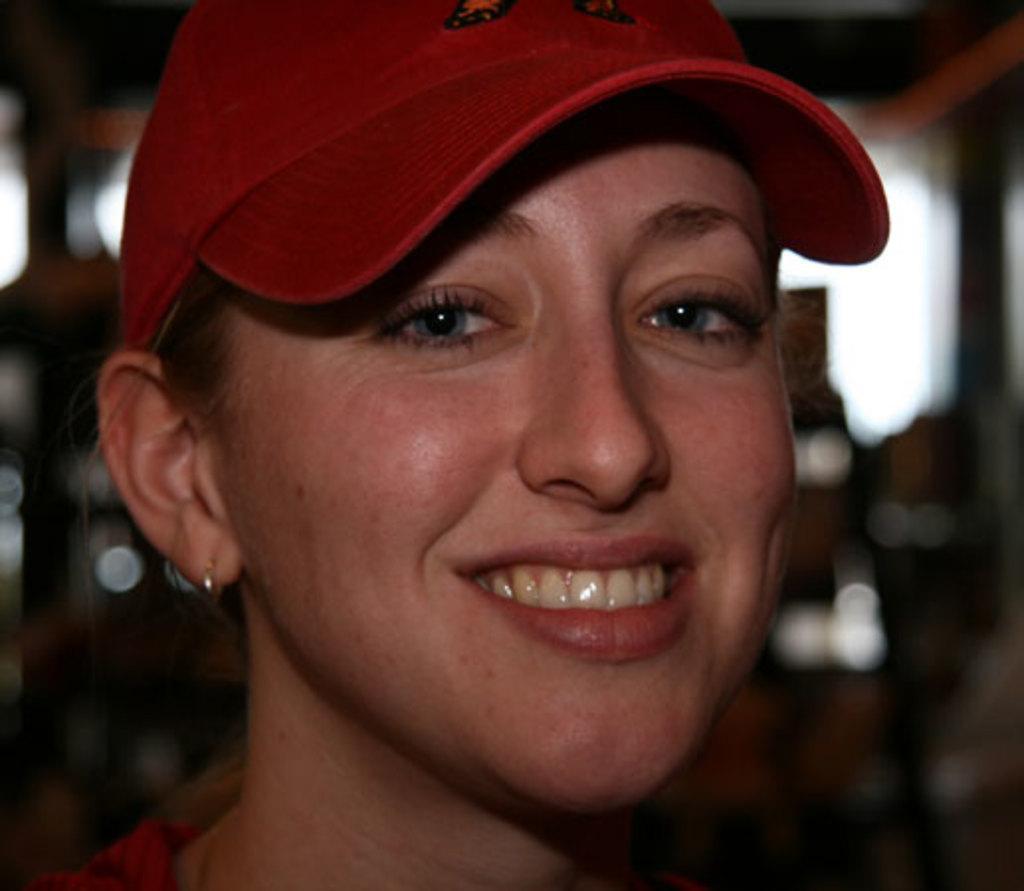Describe this image in one or two sentences. In the image we can see there is a woman who is wearing red colour cap and smiling. 